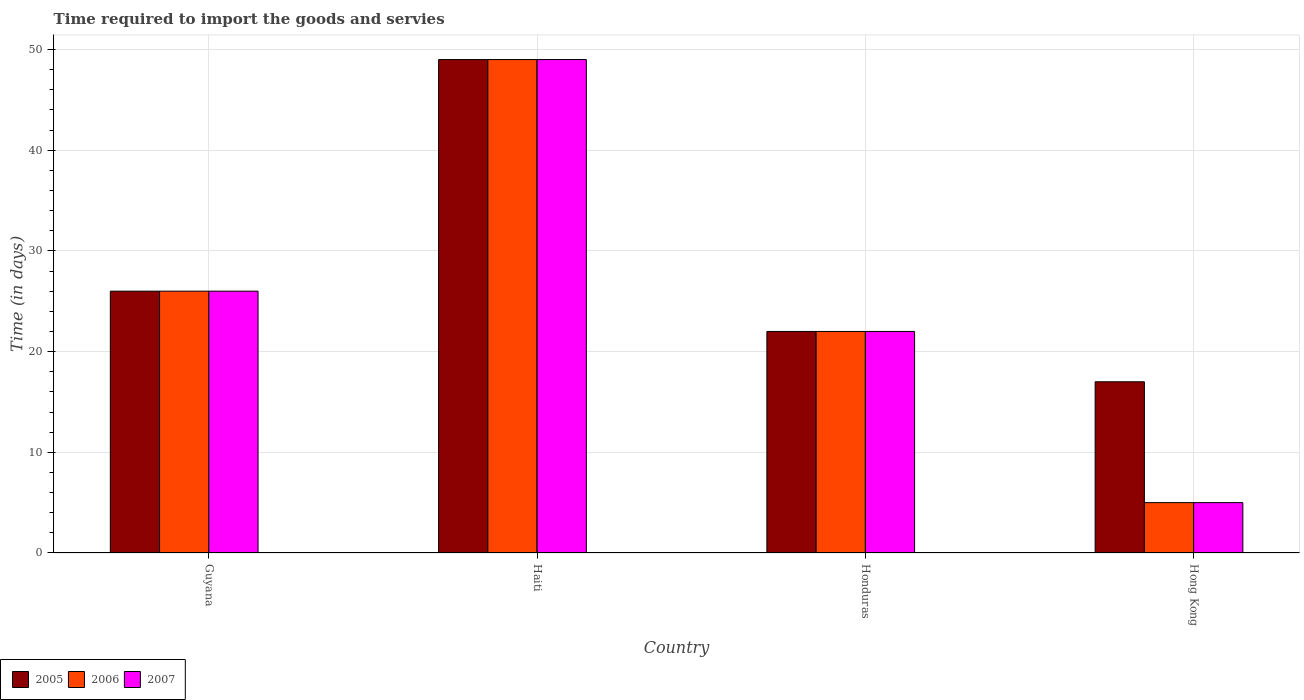Are the number of bars per tick equal to the number of legend labels?
Make the answer very short. Yes. Are the number of bars on each tick of the X-axis equal?
Provide a succinct answer. Yes. How many bars are there on the 3rd tick from the left?
Provide a short and direct response. 3. What is the label of the 2nd group of bars from the left?
Give a very brief answer. Haiti. In which country was the number of days required to import the goods and services in 2005 maximum?
Give a very brief answer. Haiti. In which country was the number of days required to import the goods and services in 2007 minimum?
Give a very brief answer. Hong Kong. What is the total number of days required to import the goods and services in 2006 in the graph?
Make the answer very short. 102. What is the difference between the number of days required to import the goods and services in 2006 in Guyana and the number of days required to import the goods and services in 2005 in Hong Kong?
Your response must be concise. 9. What is the ratio of the number of days required to import the goods and services in 2007 in Guyana to that in Haiti?
Make the answer very short. 0.53. Is the difference between the number of days required to import the goods and services in 2007 in Guyana and Hong Kong greater than the difference between the number of days required to import the goods and services in 2005 in Guyana and Hong Kong?
Your answer should be compact. Yes. In how many countries, is the number of days required to import the goods and services in 2005 greater than the average number of days required to import the goods and services in 2005 taken over all countries?
Offer a terse response. 1. What does the 3rd bar from the right in Honduras represents?
Keep it short and to the point. 2005. Is it the case that in every country, the sum of the number of days required to import the goods and services in 2005 and number of days required to import the goods and services in 2006 is greater than the number of days required to import the goods and services in 2007?
Provide a succinct answer. Yes. How many bars are there?
Offer a terse response. 12. Are all the bars in the graph horizontal?
Provide a short and direct response. No. How many countries are there in the graph?
Offer a terse response. 4. Does the graph contain any zero values?
Ensure brevity in your answer.  No. What is the title of the graph?
Ensure brevity in your answer.  Time required to import the goods and servies. Does "1970" appear as one of the legend labels in the graph?
Keep it short and to the point. No. What is the label or title of the Y-axis?
Ensure brevity in your answer.  Time (in days). What is the Time (in days) in 2006 in Guyana?
Offer a very short reply. 26. What is the Time (in days) of 2005 in Haiti?
Provide a succinct answer. 49. What is the Time (in days) of 2006 in Haiti?
Make the answer very short. 49. What is the Time (in days) in 2007 in Haiti?
Give a very brief answer. 49. What is the Time (in days) of 2007 in Honduras?
Give a very brief answer. 22. What is the Time (in days) of 2006 in Hong Kong?
Provide a short and direct response. 5. Across all countries, what is the minimum Time (in days) in 2005?
Provide a short and direct response. 17. What is the total Time (in days) in 2005 in the graph?
Provide a short and direct response. 114. What is the total Time (in days) in 2006 in the graph?
Your response must be concise. 102. What is the total Time (in days) in 2007 in the graph?
Give a very brief answer. 102. What is the difference between the Time (in days) in 2006 in Guyana and that in Honduras?
Give a very brief answer. 4. What is the difference between the Time (in days) of 2005 in Guyana and that in Hong Kong?
Provide a short and direct response. 9. What is the difference between the Time (in days) of 2006 in Guyana and that in Hong Kong?
Your answer should be compact. 21. What is the difference between the Time (in days) of 2007 in Guyana and that in Hong Kong?
Ensure brevity in your answer.  21. What is the difference between the Time (in days) of 2006 in Haiti and that in Honduras?
Provide a short and direct response. 27. What is the difference between the Time (in days) of 2007 in Haiti and that in Honduras?
Offer a very short reply. 27. What is the difference between the Time (in days) in 2005 in Haiti and that in Hong Kong?
Your answer should be very brief. 32. What is the difference between the Time (in days) of 2007 in Haiti and that in Hong Kong?
Keep it short and to the point. 44. What is the difference between the Time (in days) of 2007 in Honduras and that in Hong Kong?
Your answer should be very brief. 17. What is the difference between the Time (in days) in 2006 in Guyana and the Time (in days) in 2007 in Haiti?
Offer a very short reply. -23. What is the difference between the Time (in days) in 2005 in Guyana and the Time (in days) in 2006 in Honduras?
Ensure brevity in your answer.  4. What is the difference between the Time (in days) of 2005 in Guyana and the Time (in days) of 2007 in Honduras?
Your response must be concise. 4. What is the difference between the Time (in days) in 2006 in Guyana and the Time (in days) in 2007 in Honduras?
Your answer should be compact. 4. What is the difference between the Time (in days) of 2005 in Guyana and the Time (in days) of 2007 in Hong Kong?
Your response must be concise. 21. What is the difference between the Time (in days) of 2006 in Guyana and the Time (in days) of 2007 in Hong Kong?
Ensure brevity in your answer.  21. What is the difference between the Time (in days) of 2005 in Haiti and the Time (in days) of 2006 in Honduras?
Give a very brief answer. 27. What is the difference between the Time (in days) in 2005 in Haiti and the Time (in days) in 2007 in Honduras?
Make the answer very short. 27. What is the difference between the Time (in days) of 2005 in Haiti and the Time (in days) of 2006 in Hong Kong?
Your answer should be very brief. 44. What is the difference between the Time (in days) of 2005 in Honduras and the Time (in days) of 2007 in Hong Kong?
Offer a very short reply. 17. What is the average Time (in days) in 2005 per country?
Offer a terse response. 28.5. What is the average Time (in days) of 2006 per country?
Offer a terse response. 25.5. What is the difference between the Time (in days) in 2005 and Time (in days) in 2006 in Guyana?
Provide a short and direct response. 0. What is the difference between the Time (in days) of 2005 and Time (in days) of 2007 in Guyana?
Provide a succinct answer. 0. What is the difference between the Time (in days) of 2006 and Time (in days) of 2007 in Guyana?
Ensure brevity in your answer.  0. What is the difference between the Time (in days) in 2005 and Time (in days) in 2007 in Honduras?
Give a very brief answer. 0. What is the difference between the Time (in days) of 2005 and Time (in days) of 2006 in Hong Kong?
Make the answer very short. 12. What is the difference between the Time (in days) of 2006 and Time (in days) of 2007 in Hong Kong?
Your answer should be compact. 0. What is the ratio of the Time (in days) in 2005 in Guyana to that in Haiti?
Your response must be concise. 0.53. What is the ratio of the Time (in days) of 2006 in Guyana to that in Haiti?
Offer a terse response. 0.53. What is the ratio of the Time (in days) of 2007 in Guyana to that in Haiti?
Make the answer very short. 0.53. What is the ratio of the Time (in days) in 2005 in Guyana to that in Honduras?
Offer a terse response. 1.18. What is the ratio of the Time (in days) of 2006 in Guyana to that in Honduras?
Your response must be concise. 1.18. What is the ratio of the Time (in days) of 2007 in Guyana to that in Honduras?
Your answer should be very brief. 1.18. What is the ratio of the Time (in days) in 2005 in Guyana to that in Hong Kong?
Your answer should be compact. 1.53. What is the ratio of the Time (in days) of 2006 in Guyana to that in Hong Kong?
Your answer should be compact. 5.2. What is the ratio of the Time (in days) of 2005 in Haiti to that in Honduras?
Offer a terse response. 2.23. What is the ratio of the Time (in days) of 2006 in Haiti to that in Honduras?
Offer a terse response. 2.23. What is the ratio of the Time (in days) in 2007 in Haiti to that in Honduras?
Keep it short and to the point. 2.23. What is the ratio of the Time (in days) in 2005 in Haiti to that in Hong Kong?
Give a very brief answer. 2.88. What is the ratio of the Time (in days) of 2007 in Haiti to that in Hong Kong?
Your response must be concise. 9.8. What is the ratio of the Time (in days) of 2005 in Honduras to that in Hong Kong?
Offer a terse response. 1.29. What is the ratio of the Time (in days) of 2007 in Honduras to that in Hong Kong?
Your answer should be very brief. 4.4. What is the difference between the highest and the second highest Time (in days) of 2005?
Your answer should be very brief. 23. What is the difference between the highest and the second highest Time (in days) of 2006?
Provide a succinct answer. 23. What is the difference between the highest and the second highest Time (in days) of 2007?
Keep it short and to the point. 23. What is the difference between the highest and the lowest Time (in days) of 2006?
Offer a terse response. 44. What is the difference between the highest and the lowest Time (in days) of 2007?
Offer a terse response. 44. 